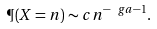<formula> <loc_0><loc_0><loc_500><loc_500>\P ( X = n ) \sim c n ^ { - \ g a - 1 } .</formula> 